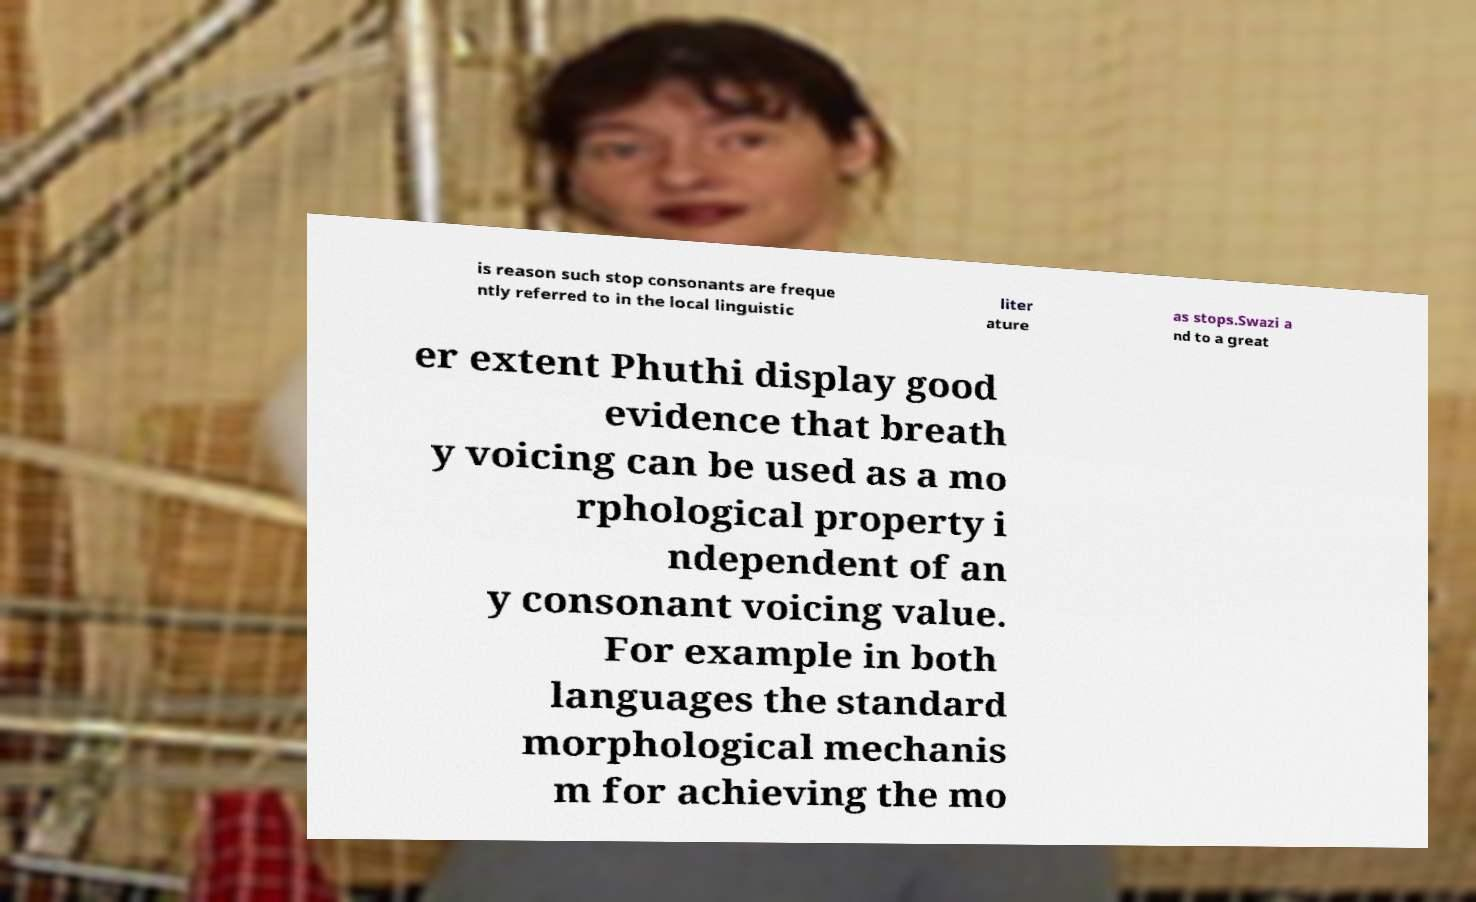Could you extract and type out the text from this image? is reason such stop consonants are freque ntly referred to in the local linguistic liter ature as stops.Swazi a nd to a great er extent Phuthi display good evidence that breath y voicing can be used as a mo rphological property i ndependent of an y consonant voicing value. For example in both languages the standard morphological mechanis m for achieving the mo 